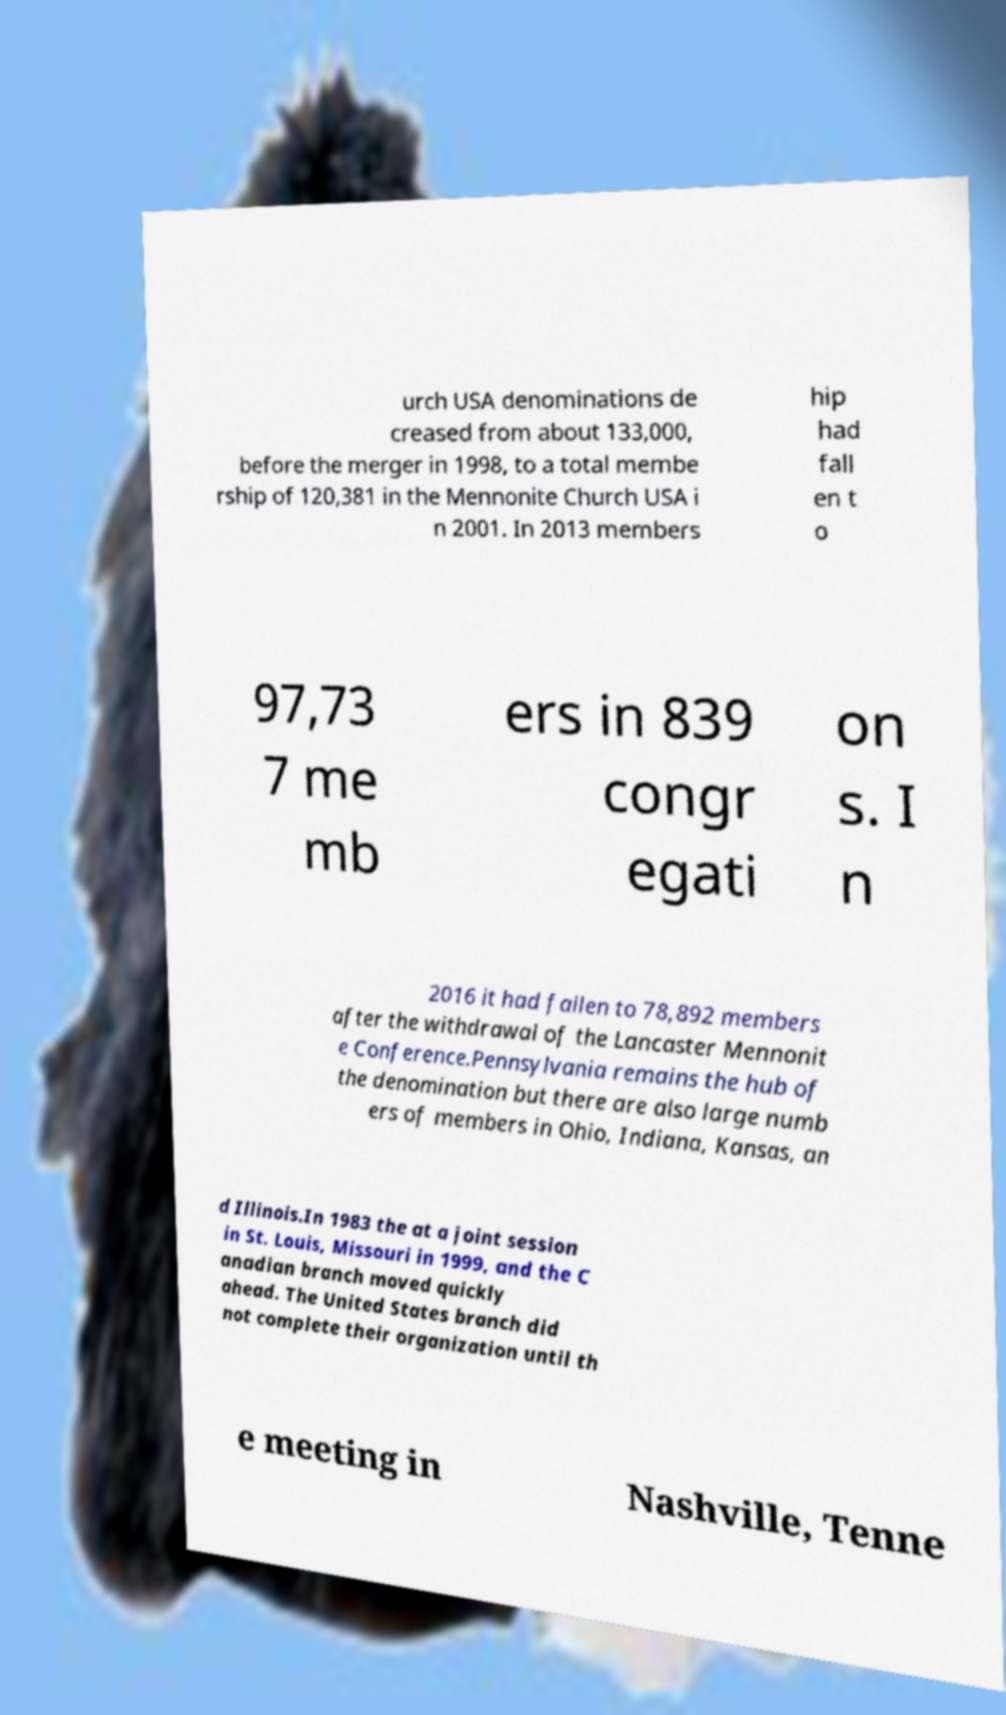Could you assist in decoding the text presented in this image and type it out clearly? urch USA denominations de creased from about 133,000, before the merger in 1998, to a total membe rship of 120,381 in the Mennonite Church USA i n 2001. In 2013 members hip had fall en t o 97,73 7 me mb ers in 839 congr egati on s. I n 2016 it had fallen to 78,892 members after the withdrawal of the Lancaster Mennonit e Conference.Pennsylvania remains the hub of the denomination but there are also large numb ers of members in Ohio, Indiana, Kansas, an d Illinois.In 1983 the at a joint session in St. Louis, Missouri in 1999, and the C anadian branch moved quickly ahead. The United States branch did not complete their organization until th e meeting in Nashville, Tenne 